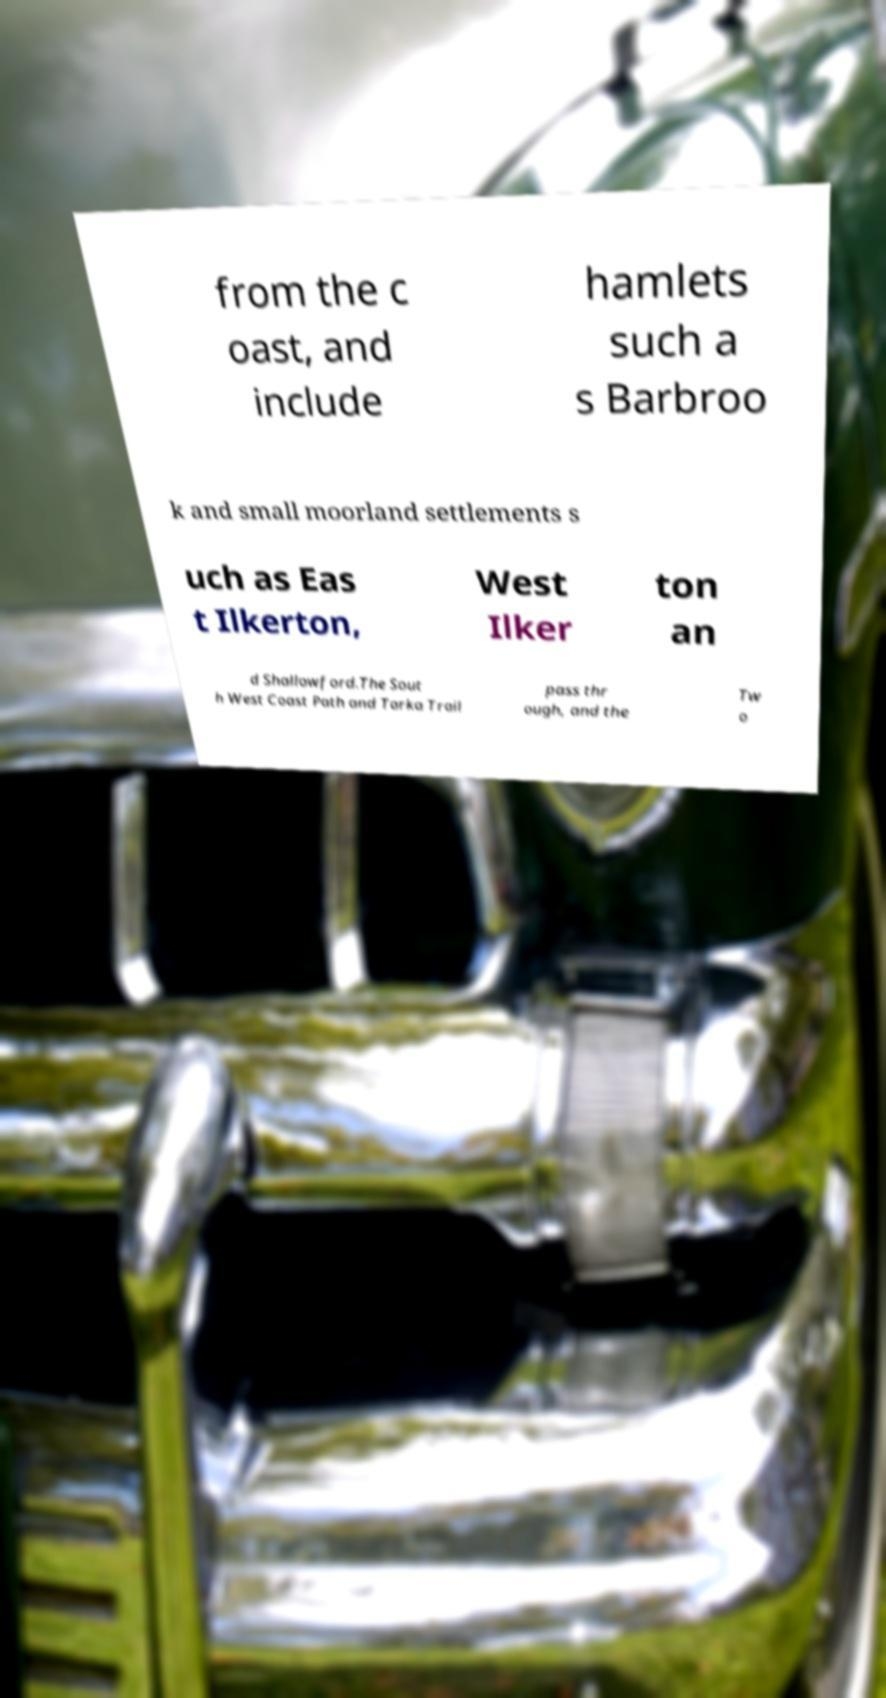For documentation purposes, I need the text within this image transcribed. Could you provide that? from the c oast, and include hamlets such a s Barbroo k and small moorland settlements s uch as Eas t Ilkerton, West Ilker ton an d Shallowford.The Sout h West Coast Path and Tarka Trail pass thr ough, and the Tw o 